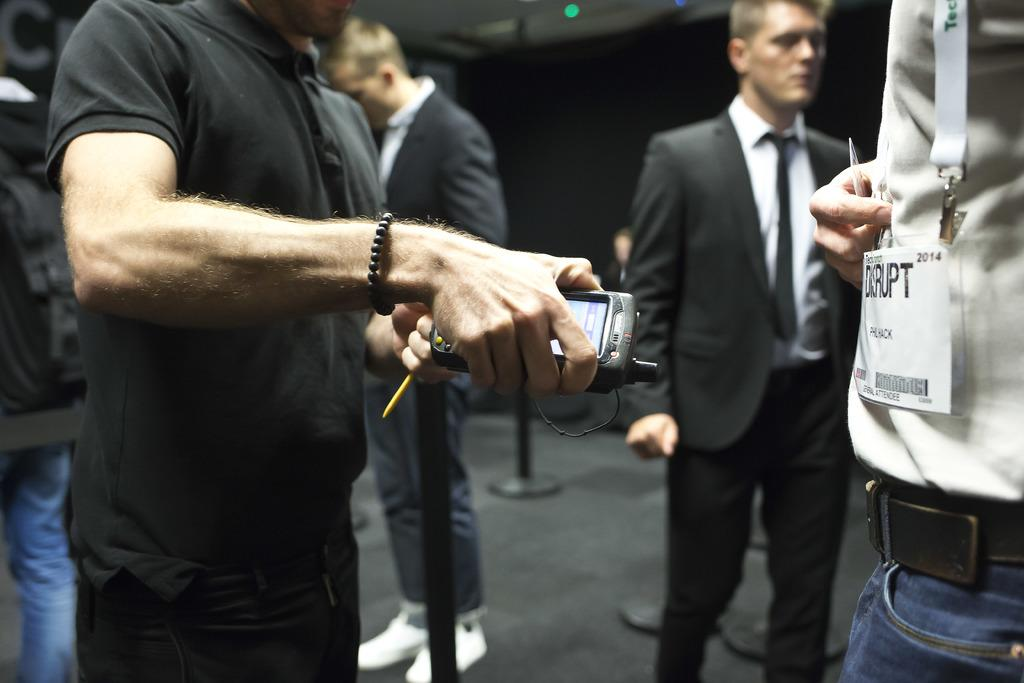What are the people in the image wearing? There is a person wearing a shirt and another person wearing a suit in the image. What is the person holding in the image? A person is holding an object in the image. How can the person with the ID card be identified? The person wearing an ID card can be identified by the card visible in the image. What is the color of the background in the image? The background of the image is black. What type of card is the person wearing as a vest in the image? There is no person wearing a card as a vest in the image. Is the person wearing a mask in the image? There is no person wearing a mask in the image. 